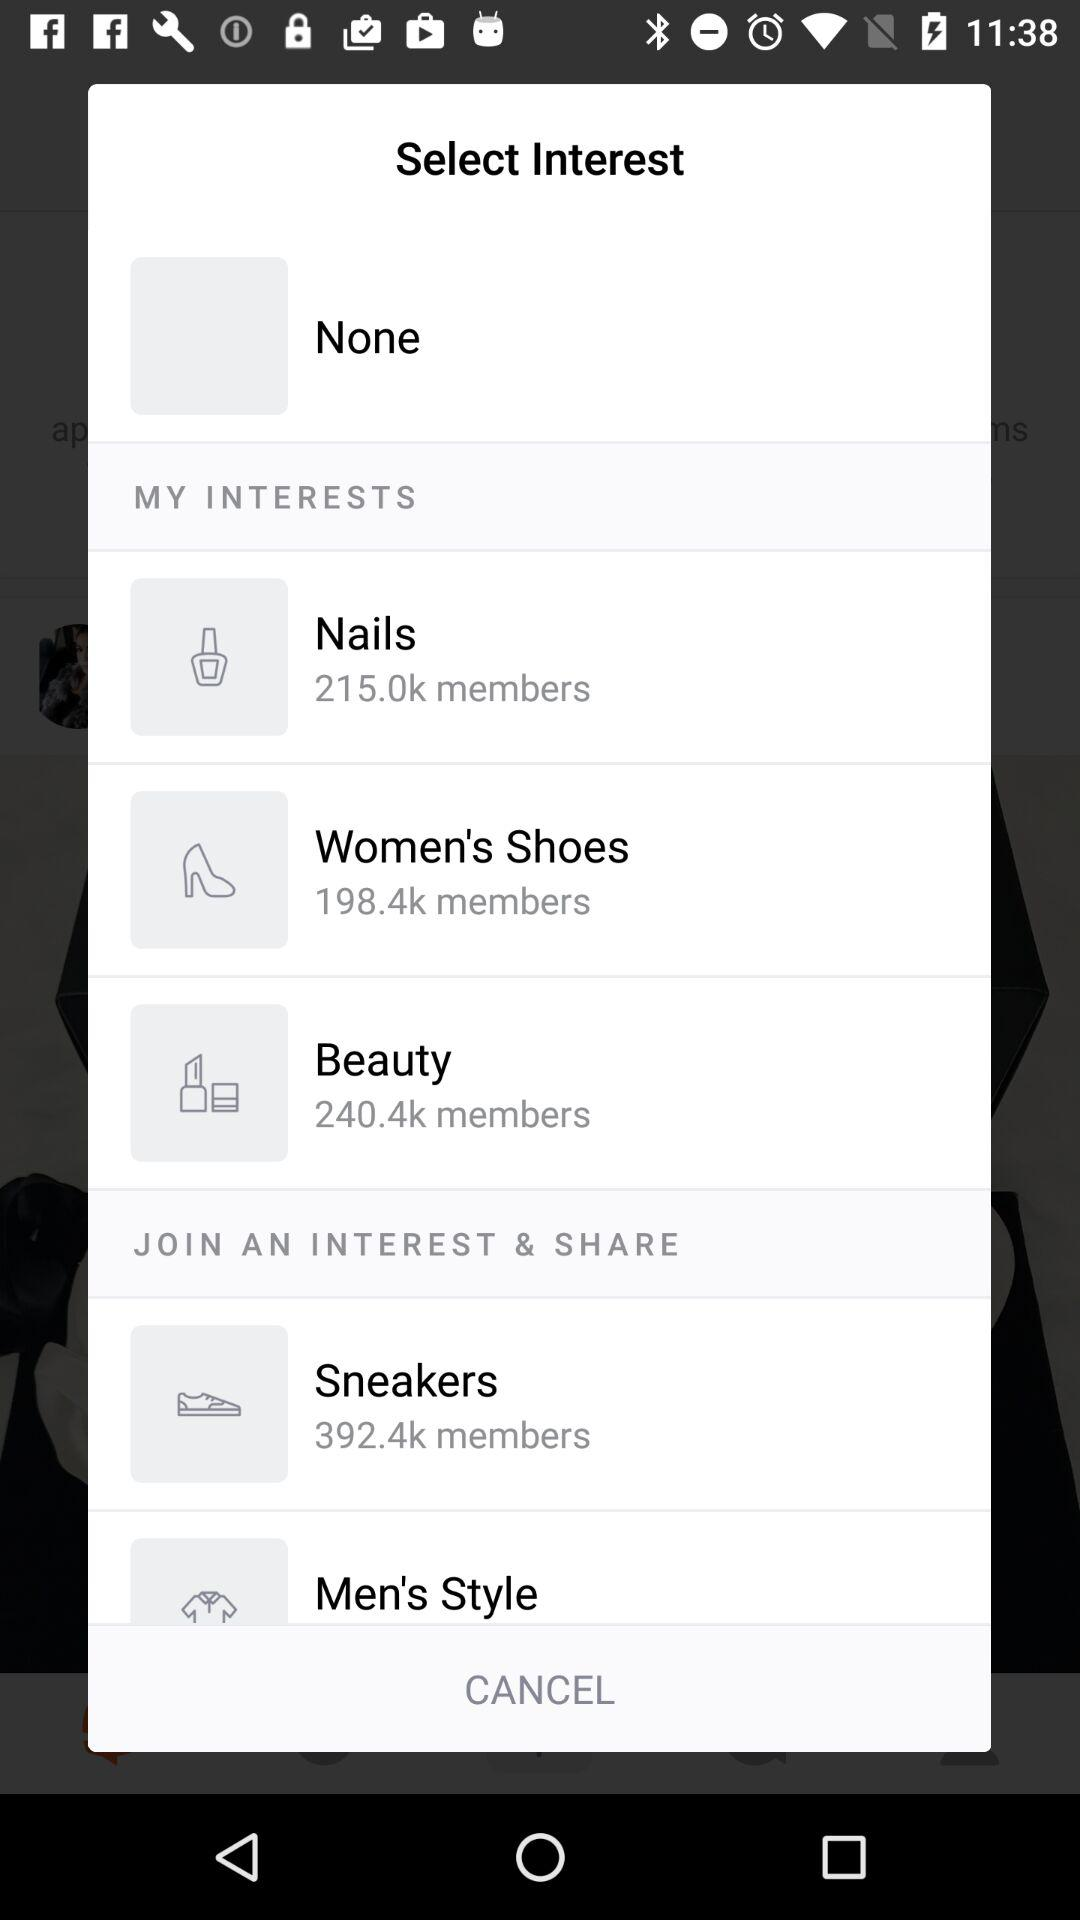How many people have expressed an interest in "Women's Shoes"? The number of people that have expressed an interest in "Women's Shoes" is 198.4k. 